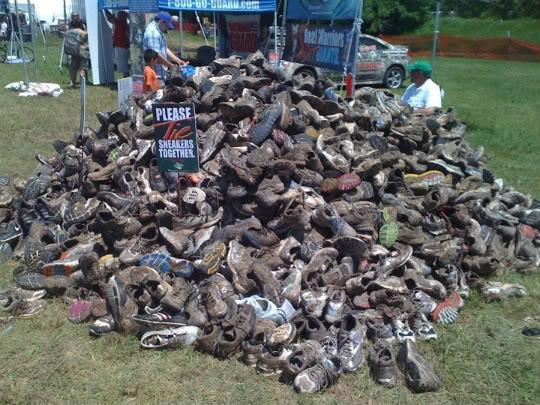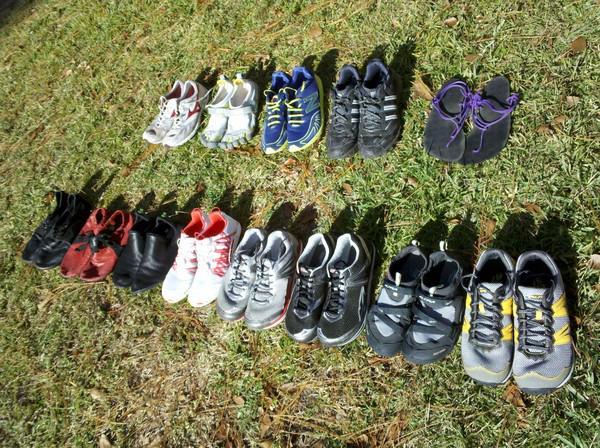The first image is the image on the left, the second image is the image on the right. Analyze the images presented: Is the assertion "An image shows two horizontal rows of shoes sitting on the grass." valid? Answer yes or no. Yes. The first image is the image on the left, the second image is the image on the right. Given the left and right images, does the statement "Shoes are piled on the grass in at least one of the images." hold true? Answer yes or no. Yes. 